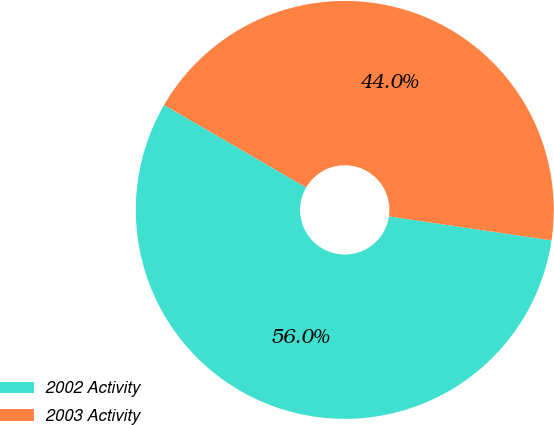<chart> <loc_0><loc_0><loc_500><loc_500><pie_chart><fcel>2002 Activity<fcel>2003 Activity<nl><fcel>56.04%<fcel>43.96%<nl></chart> 